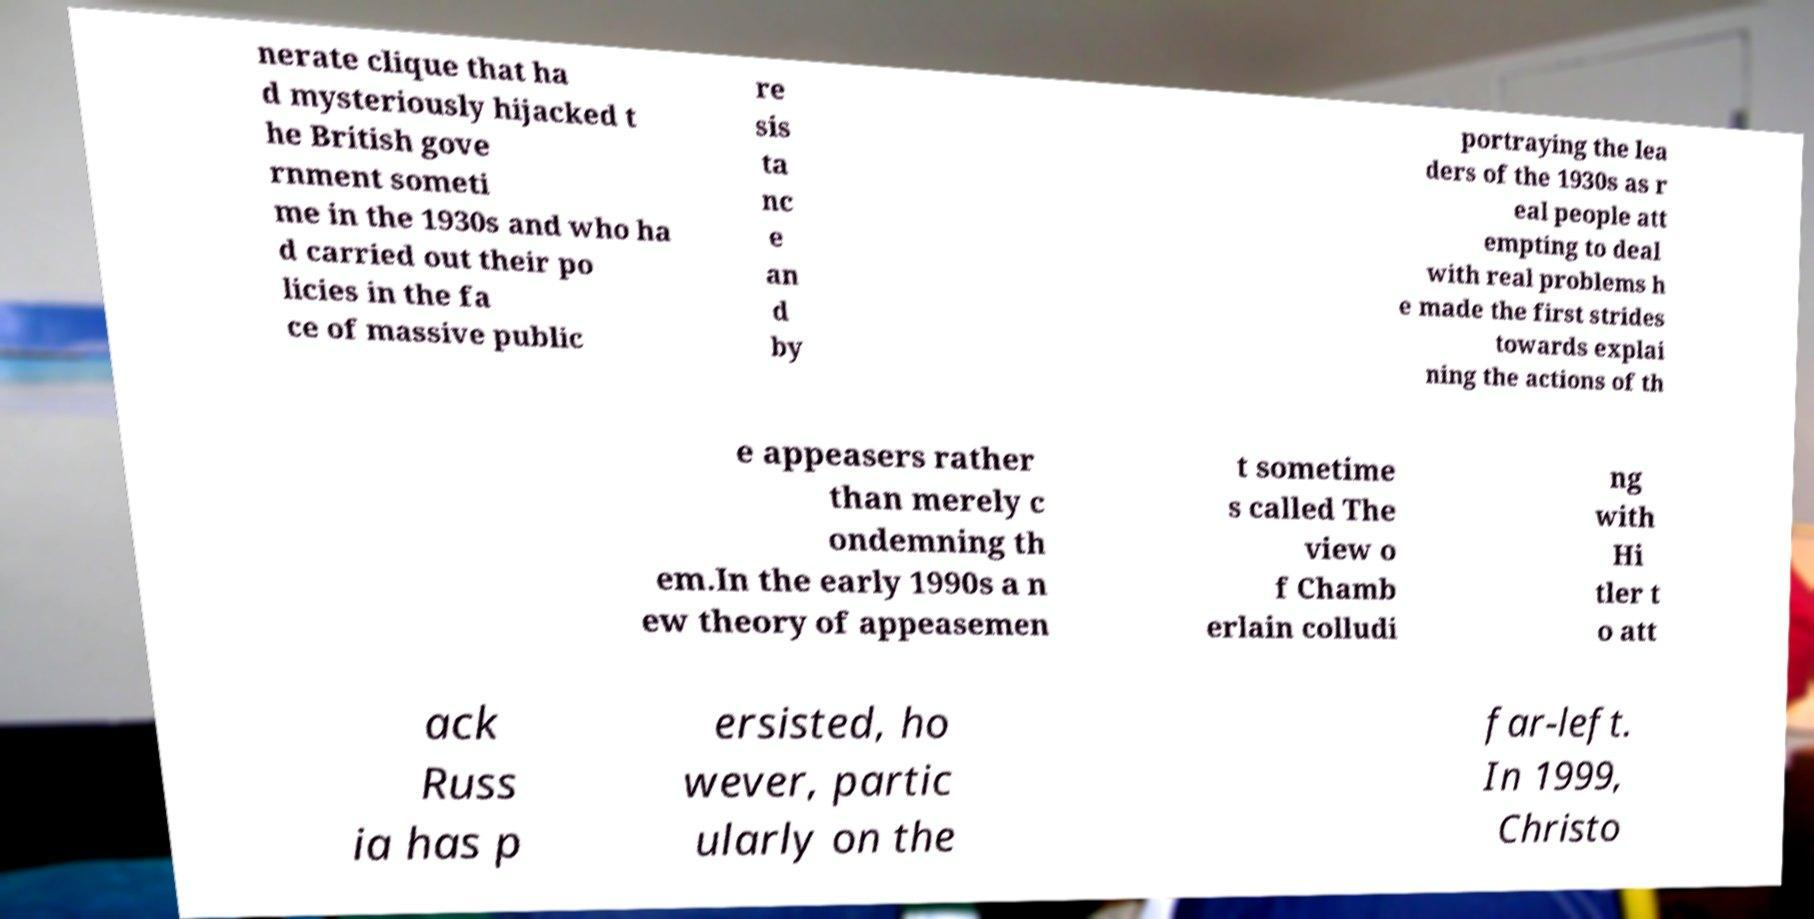Please read and relay the text visible in this image. What does it say? nerate clique that ha d mysteriously hijacked t he British gove rnment someti me in the 1930s and who ha d carried out their po licies in the fa ce of massive public re sis ta nc e an d by portraying the lea ders of the 1930s as r eal people att empting to deal with real problems h e made the first strides towards explai ning the actions of th e appeasers rather than merely c ondemning th em.In the early 1990s a n ew theory of appeasemen t sometime s called The view o f Chamb erlain colludi ng with Hi tler t o att ack Russ ia has p ersisted, ho wever, partic ularly on the far-left. In 1999, Christo 